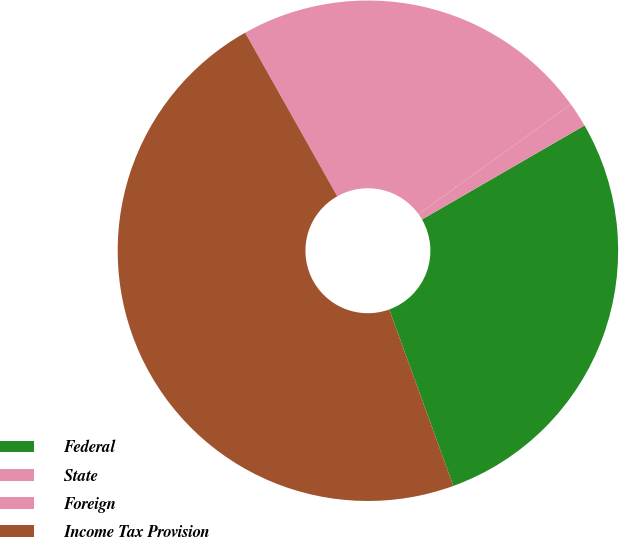Convert chart to OTSL. <chart><loc_0><loc_0><loc_500><loc_500><pie_chart><fcel>Federal<fcel>State<fcel>Foreign<fcel>Income Tax Provision<nl><fcel>27.8%<fcel>1.6%<fcel>23.22%<fcel>47.39%<nl></chart> 